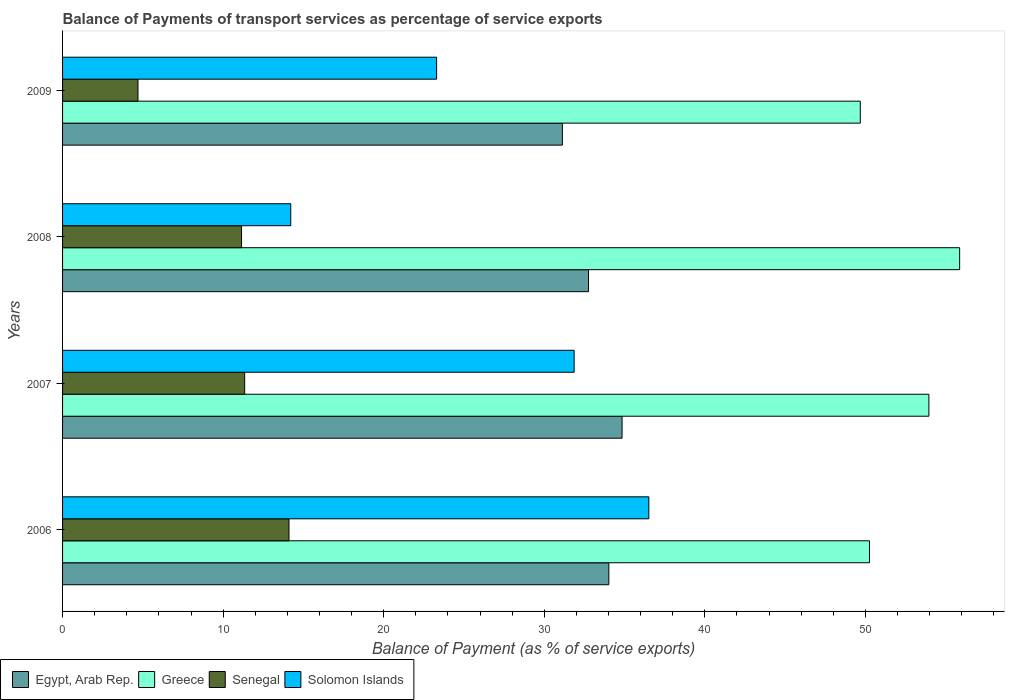How many different coloured bars are there?
Your answer should be compact. 4. How many groups of bars are there?
Provide a short and direct response. 4. Are the number of bars per tick equal to the number of legend labels?
Keep it short and to the point. Yes. Are the number of bars on each tick of the Y-axis equal?
Keep it short and to the point. Yes. How many bars are there on the 1st tick from the top?
Offer a very short reply. 4. How many bars are there on the 1st tick from the bottom?
Ensure brevity in your answer.  4. What is the label of the 4th group of bars from the top?
Offer a terse response. 2006. In how many cases, is the number of bars for a given year not equal to the number of legend labels?
Make the answer very short. 0. What is the balance of payments of transport services in Solomon Islands in 2007?
Provide a short and direct response. 31.86. Across all years, what is the maximum balance of payments of transport services in Egypt, Arab Rep.?
Offer a terse response. 34.84. Across all years, what is the minimum balance of payments of transport services in Solomon Islands?
Provide a succinct answer. 14.21. What is the total balance of payments of transport services in Solomon Islands in the graph?
Your answer should be very brief. 105.88. What is the difference between the balance of payments of transport services in Egypt, Arab Rep. in 2006 and that in 2008?
Give a very brief answer. 1.27. What is the difference between the balance of payments of transport services in Egypt, Arab Rep. in 2006 and the balance of payments of transport services in Senegal in 2008?
Your answer should be compact. 22.87. What is the average balance of payments of transport services in Solomon Islands per year?
Offer a very short reply. 26.47. In the year 2006, what is the difference between the balance of payments of transport services in Solomon Islands and balance of payments of transport services in Senegal?
Provide a succinct answer. 22.41. What is the ratio of the balance of payments of transport services in Senegal in 2007 to that in 2008?
Your response must be concise. 1.02. Is the balance of payments of transport services in Senegal in 2007 less than that in 2009?
Your answer should be very brief. No. What is the difference between the highest and the second highest balance of payments of transport services in Senegal?
Give a very brief answer. 2.76. What is the difference between the highest and the lowest balance of payments of transport services in Greece?
Provide a short and direct response. 6.19. Is it the case that in every year, the sum of the balance of payments of transport services in Solomon Islands and balance of payments of transport services in Senegal is greater than the sum of balance of payments of transport services in Egypt, Arab Rep. and balance of payments of transport services in Greece?
Provide a succinct answer. Yes. What does the 1st bar from the top in 2009 represents?
Provide a succinct answer. Solomon Islands. What does the 3rd bar from the bottom in 2006 represents?
Provide a short and direct response. Senegal. Is it the case that in every year, the sum of the balance of payments of transport services in Greece and balance of payments of transport services in Senegal is greater than the balance of payments of transport services in Solomon Islands?
Provide a succinct answer. Yes. How many bars are there?
Offer a very short reply. 16. What is the difference between two consecutive major ticks on the X-axis?
Offer a terse response. 10. Are the values on the major ticks of X-axis written in scientific E-notation?
Provide a succinct answer. No. Does the graph contain any zero values?
Keep it short and to the point. No. How are the legend labels stacked?
Provide a short and direct response. Horizontal. What is the title of the graph?
Offer a terse response. Balance of Payments of transport services as percentage of service exports. What is the label or title of the X-axis?
Provide a short and direct response. Balance of Payment (as % of service exports). What is the label or title of the Y-axis?
Your response must be concise. Years. What is the Balance of Payment (as % of service exports) of Egypt, Arab Rep. in 2006?
Keep it short and to the point. 34.02. What is the Balance of Payment (as % of service exports) in Greece in 2006?
Your answer should be very brief. 50.25. What is the Balance of Payment (as % of service exports) in Senegal in 2006?
Keep it short and to the point. 14.1. What is the Balance of Payment (as % of service exports) of Solomon Islands in 2006?
Your response must be concise. 36.51. What is the Balance of Payment (as % of service exports) in Egypt, Arab Rep. in 2007?
Offer a terse response. 34.84. What is the Balance of Payment (as % of service exports) of Greece in 2007?
Ensure brevity in your answer.  53.95. What is the Balance of Payment (as % of service exports) of Senegal in 2007?
Ensure brevity in your answer.  11.34. What is the Balance of Payment (as % of service exports) in Solomon Islands in 2007?
Provide a succinct answer. 31.86. What is the Balance of Payment (as % of service exports) in Egypt, Arab Rep. in 2008?
Your answer should be compact. 32.76. What is the Balance of Payment (as % of service exports) of Greece in 2008?
Give a very brief answer. 55.87. What is the Balance of Payment (as % of service exports) of Senegal in 2008?
Your response must be concise. 11.15. What is the Balance of Payment (as % of service exports) of Solomon Islands in 2008?
Provide a succinct answer. 14.21. What is the Balance of Payment (as % of service exports) of Egypt, Arab Rep. in 2009?
Your answer should be compact. 31.13. What is the Balance of Payment (as % of service exports) in Greece in 2009?
Your answer should be compact. 49.68. What is the Balance of Payment (as % of service exports) of Senegal in 2009?
Your answer should be compact. 4.7. What is the Balance of Payment (as % of service exports) in Solomon Islands in 2009?
Keep it short and to the point. 23.29. Across all years, what is the maximum Balance of Payment (as % of service exports) of Egypt, Arab Rep.?
Your answer should be very brief. 34.84. Across all years, what is the maximum Balance of Payment (as % of service exports) in Greece?
Your answer should be compact. 55.87. Across all years, what is the maximum Balance of Payment (as % of service exports) of Senegal?
Your answer should be compact. 14.1. Across all years, what is the maximum Balance of Payment (as % of service exports) in Solomon Islands?
Give a very brief answer. 36.51. Across all years, what is the minimum Balance of Payment (as % of service exports) of Egypt, Arab Rep.?
Provide a short and direct response. 31.13. Across all years, what is the minimum Balance of Payment (as % of service exports) in Greece?
Make the answer very short. 49.68. Across all years, what is the minimum Balance of Payment (as % of service exports) in Senegal?
Your response must be concise. 4.7. Across all years, what is the minimum Balance of Payment (as % of service exports) in Solomon Islands?
Give a very brief answer. 14.21. What is the total Balance of Payment (as % of service exports) of Egypt, Arab Rep. in the graph?
Provide a short and direct response. 132.75. What is the total Balance of Payment (as % of service exports) of Greece in the graph?
Offer a terse response. 209.75. What is the total Balance of Payment (as % of service exports) of Senegal in the graph?
Offer a terse response. 41.29. What is the total Balance of Payment (as % of service exports) in Solomon Islands in the graph?
Provide a short and direct response. 105.88. What is the difference between the Balance of Payment (as % of service exports) of Egypt, Arab Rep. in 2006 and that in 2007?
Make the answer very short. -0.82. What is the difference between the Balance of Payment (as % of service exports) in Greece in 2006 and that in 2007?
Keep it short and to the point. -3.7. What is the difference between the Balance of Payment (as % of service exports) of Senegal in 2006 and that in 2007?
Provide a succinct answer. 2.76. What is the difference between the Balance of Payment (as % of service exports) of Solomon Islands in 2006 and that in 2007?
Provide a succinct answer. 4.65. What is the difference between the Balance of Payment (as % of service exports) of Egypt, Arab Rep. in 2006 and that in 2008?
Offer a very short reply. 1.27. What is the difference between the Balance of Payment (as % of service exports) of Greece in 2006 and that in 2008?
Provide a short and direct response. -5.61. What is the difference between the Balance of Payment (as % of service exports) of Senegal in 2006 and that in 2008?
Keep it short and to the point. 2.95. What is the difference between the Balance of Payment (as % of service exports) in Solomon Islands in 2006 and that in 2008?
Make the answer very short. 22.3. What is the difference between the Balance of Payment (as % of service exports) of Egypt, Arab Rep. in 2006 and that in 2009?
Provide a short and direct response. 2.89. What is the difference between the Balance of Payment (as % of service exports) of Greece in 2006 and that in 2009?
Keep it short and to the point. 0.57. What is the difference between the Balance of Payment (as % of service exports) of Senegal in 2006 and that in 2009?
Your answer should be compact. 9.4. What is the difference between the Balance of Payment (as % of service exports) in Solomon Islands in 2006 and that in 2009?
Keep it short and to the point. 13.22. What is the difference between the Balance of Payment (as % of service exports) in Egypt, Arab Rep. in 2007 and that in 2008?
Give a very brief answer. 2.09. What is the difference between the Balance of Payment (as % of service exports) of Greece in 2007 and that in 2008?
Offer a terse response. -1.92. What is the difference between the Balance of Payment (as % of service exports) of Senegal in 2007 and that in 2008?
Provide a short and direct response. 0.19. What is the difference between the Balance of Payment (as % of service exports) in Solomon Islands in 2007 and that in 2008?
Ensure brevity in your answer.  17.65. What is the difference between the Balance of Payment (as % of service exports) in Egypt, Arab Rep. in 2007 and that in 2009?
Offer a terse response. 3.72. What is the difference between the Balance of Payment (as % of service exports) of Greece in 2007 and that in 2009?
Offer a terse response. 4.27. What is the difference between the Balance of Payment (as % of service exports) of Senegal in 2007 and that in 2009?
Keep it short and to the point. 6.64. What is the difference between the Balance of Payment (as % of service exports) in Solomon Islands in 2007 and that in 2009?
Ensure brevity in your answer.  8.57. What is the difference between the Balance of Payment (as % of service exports) of Egypt, Arab Rep. in 2008 and that in 2009?
Make the answer very short. 1.63. What is the difference between the Balance of Payment (as % of service exports) in Greece in 2008 and that in 2009?
Offer a very short reply. 6.19. What is the difference between the Balance of Payment (as % of service exports) of Senegal in 2008 and that in 2009?
Keep it short and to the point. 6.45. What is the difference between the Balance of Payment (as % of service exports) in Solomon Islands in 2008 and that in 2009?
Provide a short and direct response. -9.08. What is the difference between the Balance of Payment (as % of service exports) in Egypt, Arab Rep. in 2006 and the Balance of Payment (as % of service exports) in Greece in 2007?
Your answer should be compact. -19.93. What is the difference between the Balance of Payment (as % of service exports) in Egypt, Arab Rep. in 2006 and the Balance of Payment (as % of service exports) in Senegal in 2007?
Give a very brief answer. 22.68. What is the difference between the Balance of Payment (as % of service exports) of Egypt, Arab Rep. in 2006 and the Balance of Payment (as % of service exports) of Solomon Islands in 2007?
Provide a succinct answer. 2.16. What is the difference between the Balance of Payment (as % of service exports) in Greece in 2006 and the Balance of Payment (as % of service exports) in Senegal in 2007?
Make the answer very short. 38.91. What is the difference between the Balance of Payment (as % of service exports) in Greece in 2006 and the Balance of Payment (as % of service exports) in Solomon Islands in 2007?
Provide a succinct answer. 18.39. What is the difference between the Balance of Payment (as % of service exports) in Senegal in 2006 and the Balance of Payment (as % of service exports) in Solomon Islands in 2007?
Give a very brief answer. -17.76. What is the difference between the Balance of Payment (as % of service exports) of Egypt, Arab Rep. in 2006 and the Balance of Payment (as % of service exports) of Greece in 2008?
Give a very brief answer. -21.85. What is the difference between the Balance of Payment (as % of service exports) in Egypt, Arab Rep. in 2006 and the Balance of Payment (as % of service exports) in Senegal in 2008?
Make the answer very short. 22.87. What is the difference between the Balance of Payment (as % of service exports) in Egypt, Arab Rep. in 2006 and the Balance of Payment (as % of service exports) in Solomon Islands in 2008?
Make the answer very short. 19.81. What is the difference between the Balance of Payment (as % of service exports) in Greece in 2006 and the Balance of Payment (as % of service exports) in Senegal in 2008?
Ensure brevity in your answer.  39.11. What is the difference between the Balance of Payment (as % of service exports) in Greece in 2006 and the Balance of Payment (as % of service exports) in Solomon Islands in 2008?
Your response must be concise. 36.04. What is the difference between the Balance of Payment (as % of service exports) of Senegal in 2006 and the Balance of Payment (as % of service exports) of Solomon Islands in 2008?
Your response must be concise. -0.11. What is the difference between the Balance of Payment (as % of service exports) in Egypt, Arab Rep. in 2006 and the Balance of Payment (as % of service exports) in Greece in 2009?
Offer a terse response. -15.66. What is the difference between the Balance of Payment (as % of service exports) in Egypt, Arab Rep. in 2006 and the Balance of Payment (as % of service exports) in Senegal in 2009?
Offer a very short reply. 29.32. What is the difference between the Balance of Payment (as % of service exports) in Egypt, Arab Rep. in 2006 and the Balance of Payment (as % of service exports) in Solomon Islands in 2009?
Your answer should be very brief. 10.73. What is the difference between the Balance of Payment (as % of service exports) in Greece in 2006 and the Balance of Payment (as % of service exports) in Senegal in 2009?
Make the answer very short. 45.56. What is the difference between the Balance of Payment (as % of service exports) in Greece in 2006 and the Balance of Payment (as % of service exports) in Solomon Islands in 2009?
Your answer should be compact. 26.96. What is the difference between the Balance of Payment (as % of service exports) of Senegal in 2006 and the Balance of Payment (as % of service exports) of Solomon Islands in 2009?
Provide a short and direct response. -9.19. What is the difference between the Balance of Payment (as % of service exports) in Egypt, Arab Rep. in 2007 and the Balance of Payment (as % of service exports) in Greece in 2008?
Make the answer very short. -21.02. What is the difference between the Balance of Payment (as % of service exports) in Egypt, Arab Rep. in 2007 and the Balance of Payment (as % of service exports) in Senegal in 2008?
Offer a terse response. 23.7. What is the difference between the Balance of Payment (as % of service exports) of Egypt, Arab Rep. in 2007 and the Balance of Payment (as % of service exports) of Solomon Islands in 2008?
Your answer should be compact. 20.63. What is the difference between the Balance of Payment (as % of service exports) in Greece in 2007 and the Balance of Payment (as % of service exports) in Senegal in 2008?
Offer a very short reply. 42.81. What is the difference between the Balance of Payment (as % of service exports) in Greece in 2007 and the Balance of Payment (as % of service exports) in Solomon Islands in 2008?
Keep it short and to the point. 39.74. What is the difference between the Balance of Payment (as % of service exports) in Senegal in 2007 and the Balance of Payment (as % of service exports) in Solomon Islands in 2008?
Give a very brief answer. -2.87. What is the difference between the Balance of Payment (as % of service exports) in Egypt, Arab Rep. in 2007 and the Balance of Payment (as % of service exports) in Greece in 2009?
Give a very brief answer. -14.84. What is the difference between the Balance of Payment (as % of service exports) in Egypt, Arab Rep. in 2007 and the Balance of Payment (as % of service exports) in Senegal in 2009?
Make the answer very short. 30.15. What is the difference between the Balance of Payment (as % of service exports) in Egypt, Arab Rep. in 2007 and the Balance of Payment (as % of service exports) in Solomon Islands in 2009?
Offer a terse response. 11.55. What is the difference between the Balance of Payment (as % of service exports) of Greece in 2007 and the Balance of Payment (as % of service exports) of Senegal in 2009?
Give a very brief answer. 49.26. What is the difference between the Balance of Payment (as % of service exports) of Greece in 2007 and the Balance of Payment (as % of service exports) of Solomon Islands in 2009?
Provide a short and direct response. 30.66. What is the difference between the Balance of Payment (as % of service exports) of Senegal in 2007 and the Balance of Payment (as % of service exports) of Solomon Islands in 2009?
Ensure brevity in your answer.  -11.95. What is the difference between the Balance of Payment (as % of service exports) in Egypt, Arab Rep. in 2008 and the Balance of Payment (as % of service exports) in Greece in 2009?
Ensure brevity in your answer.  -16.93. What is the difference between the Balance of Payment (as % of service exports) of Egypt, Arab Rep. in 2008 and the Balance of Payment (as % of service exports) of Senegal in 2009?
Offer a terse response. 28.06. What is the difference between the Balance of Payment (as % of service exports) in Egypt, Arab Rep. in 2008 and the Balance of Payment (as % of service exports) in Solomon Islands in 2009?
Your answer should be very brief. 9.46. What is the difference between the Balance of Payment (as % of service exports) of Greece in 2008 and the Balance of Payment (as % of service exports) of Senegal in 2009?
Offer a very short reply. 51.17. What is the difference between the Balance of Payment (as % of service exports) of Greece in 2008 and the Balance of Payment (as % of service exports) of Solomon Islands in 2009?
Your answer should be very brief. 32.57. What is the difference between the Balance of Payment (as % of service exports) in Senegal in 2008 and the Balance of Payment (as % of service exports) in Solomon Islands in 2009?
Provide a succinct answer. -12.15. What is the average Balance of Payment (as % of service exports) in Egypt, Arab Rep. per year?
Your response must be concise. 33.19. What is the average Balance of Payment (as % of service exports) in Greece per year?
Offer a terse response. 52.44. What is the average Balance of Payment (as % of service exports) of Senegal per year?
Your response must be concise. 10.32. What is the average Balance of Payment (as % of service exports) of Solomon Islands per year?
Provide a succinct answer. 26.47. In the year 2006, what is the difference between the Balance of Payment (as % of service exports) in Egypt, Arab Rep. and Balance of Payment (as % of service exports) in Greece?
Keep it short and to the point. -16.23. In the year 2006, what is the difference between the Balance of Payment (as % of service exports) in Egypt, Arab Rep. and Balance of Payment (as % of service exports) in Senegal?
Keep it short and to the point. 19.92. In the year 2006, what is the difference between the Balance of Payment (as % of service exports) in Egypt, Arab Rep. and Balance of Payment (as % of service exports) in Solomon Islands?
Ensure brevity in your answer.  -2.49. In the year 2006, what is the difference between the Balance of Payment (as % of service exports) of Greece and Balance of Payment (as % of service exports) of Senegal?
Give a very brief answer. 36.15. In the year 2006, what is the difference between the Balance of Payment (as % of service exports) of Greece and Balance of Payment (as % of service exports) of Solomon Islands?
Ensure brevity in your answer.  13.74. In the year 2006, what is the difference between the Balance of Payment (as % of service exports) in Senegal and Balance of Payment (as % of service exports) in Solomon Islands?
Your answer should be compact. -22.41. In the year 2007, what is the difference between the Balance of Payment (as % of service exports) of Egypt, Arab Rep. and Balance of Payment (as % of service exports) of Greece?
Make the answer very short. -19.11. In the year 2007, what is the difference between the Balance of Payment (as % of service exports) of Egypt, Arab Rep. and Balance of Payment (as % of service exports) of Senegal?
Your answer should be very brief. 23.5. In the year 2007, what is the difference between the Balance of Payment (as % of service exports) in Egypt, Arab Rep. and Balance of Payment (as % of service exports) in Solomon Islands?
Give a very brief answer. 2.98. In the year 2007, what is the difference between the Balance of Payment (as % of service exports) in Greece and Balance of Payment (as % of service exports) in Senegal?
Offer a terse response. 42.61. In the year 2007, what is the difference between the Balance of Payment (as % of service exports) of Greece and Balance of Payment (as % of service exports) of Solomon Islands?
Give a very brief answer. 22.09. In the year 2007, what is the difference between the Balance of Payment (as % of service exports) in Senegal and Balance of Payment (as % of service exports) in Solomon Islands?
Your answer should be very brief. -20.52. In the year 2008, what is the difference between the Balance of Payment (as % of service exports) in Egypt, Arab Rep. and Balance of Payment (as % of service exports) in Greece?
Your answer should be very brief. -23.11. In the year 2008, what is the difference between the Balance of Payment (as % of service exports) of Egypt, Arab Rep. and Balance of Payment (as % of service exports) of Senegal?
Your response must be concise. 21.61. In the year 2008, what is the difference between the Balance of Payment (as % of service exports) in Egypt, Arab Rep. and Balance of Payment (as % of service exports) in Solomon Islands?
Offer a terse response. 18.54. In the year 2008, what is the difference between the Balance of Payment (as % of service exports) of Greece and Balance of Payment (as % of service exports) of Senegal?
Your response must be concise. 44.72. In the year 2008, what is the difference between the Balance of Payment (as % of service exports) in Greece and Balance of Payment (as % of service exports) in Solomon Islands?
Offer a terse response. 41.66. In the year 2008, what is the difference between the Balance of Payment (as % of service exports) of Senegal and Balance of Payment (as % of service exports) of Solomon Islands?
Ensure brevity in your answer.  -3.06. In the year 2009, what is the difference between the Balance of Payment (as % of service exports) of Egypt, Arab Rep. and Balance of Payment (as % of service exports) of Greece?
Offer a very short reply. -18.55. In the year 2009, what is the difference between the Balance of Payment (as % of service exports) in Egypt, Arab Rep. and Balance of Payment (as % of service exports) in Senegal?
Ensure brevity in your answer.  26.43. In the year 2009, what is the difference between the Balance of Payment (as % of service exports) in Egypt, Arab Rep. and Balance of Payment (as % of service exports) in Solomon Islands?
Provide a succinct answer. 7.83. In the year 2009, what is the difference between the Balance of Payment (as % of service exports) of Greece and Balance of Payment (as % of service exports) of Senegal?
Offer a very short reply. 44.98. In the year 2009, what is the difference between the Balance of Payment (as % of service exports) of Greece and Balance of Payment (as % of service exports) of Solomon Islands?
Offer a terse response. 26.39. In the year 2009, what is the difference between the Balance of Payment (as % of service exports) in Senegal and Balance of Payment (as % of service exports) in Solomon Islands?
Your response must be concise. -18.6. What is the ratio of the Balance of Payment (as % of service exports) of Egypt, Arab Rep. in 2006 to that in 2007?
Keep it short and to the point. 0.98. What is the ratio of the Balance of Payment (as % of service exports) of Greece in 2006 to that in 2007?
Provide a succinct answer. 0.93. What is the ratio of the Balance of Payment (as % of service exports) of Senegal in 2006 to that in 2007?
Your response must be concise. 1.24. What is the ratio of the Balance of Payment (as % of service exports) of Solomon Islands in 2006 to that in 2007?
Offer a terse response. 1.15. What is the ratio of the Balance of Payment (as % of service exports) of Egypt, Arab Rep. in 2006 to that in 2008?
Keep it short and to the point. 1.04. What is the ratio of the Balance of Payment (as % of service exports) of Greece in 2006 to that in 2008?
Your answer should be very brief. 0.9. What is the ratio of the Balance of Payment (as % of service exports) of Senegal in 2006 to that in 2008?
Provide a succinct answer. 1.26. What is the ratio of the Balance of Payment (as % of service exports) in Solomon Islands in 2006 to that in 2008?
Provide a succinct answer. 2.57. What is the ratio of the Balance of Payment (as % of service exports) of Egypt, Arab Rep. in 2006 to that in 2009?
Give a very brief answer. 1.09. What is the ratio of the Balance of Payment (as % of service exports) of Greece in 2006 to that in 2009?
Your answer should be very brief. 1.01. What is the ratio of the Balance of Payment (as % of service exports) of Senegal in 2006 to that in 2009?
Your response must be concise. 3. What is the ratio of the Balance of Payment (as % of service exports) of Solomon Islands in 2006 to that in 2009?
Offer a very short reply. 1.57. What is the ratio of the Balance of Payment (as % of service exports) of Egypt, Arab Rep. in 2007 to that in 2008?
Your answer should be compact. 1.06. What is the ratio of the Balance of Payment (as % of service exports) in Greece in 2007 to that in 2008?
Provide a succinct answer. 0.97. What is the ratio of the Balance of Payment (as % of service exports) in Senegal in 2007 to that in 2008?
Offer a terse response. 1.02. What is the ratio of the Balance of Payment (as % of service exports) of Solomon Islands in 2007 to that in 2008?
Provide a succinct answer. 2.24. What is the ratio of the Balance of Payment (as % of service exports) of Egypt, Arab Rep. in 2007 to that in 2009?
Keep it short and to the point. 1.12. What is the ratio of the Balance of Payment (as % of service exports) in Greece in 2007 to that in 2009?
Offer a terse response. 1.09. What is the ratio of the Balance of Payment (as % of service exports) in Senegal in 2007 to that in 2009?
Give a very brief answer. 2.41. What is the ratio of the Balance of Payment (as % of service exports) of Solomon Islands in 2007 to that in 2009?
Your answer should be very brief. 1.37. What is the ratio of the Balance of Payment (as % of service exports) of Egypt, Arab Rep. in 2008 to that in 2009?
Ensure brevity in your answer.  1.05. What is the ratio of the Balance of Payment (as % of service exports) of Greece in 2008 to that in 2009?
Provide a succinct answer. 1.12. What is the ratio of the Balance of Payment (as % of service exports) of Senegal in 2008 to that in 2009?
Your answer should be very brief. 2.37. What is the ratio of the Balance of Payment (as % of service exports) in Solomon Islands in 2008 to that in 2009?
Give a very brief answer. 0.61. What is the difference between the highest and the second highest Balance of Payment (as % of service exports) of Egypt, Arab Rep.?
Keep it short and to the point. 0.82. What is the difference between the highest and the second highest Balance of Payment (as % of service exports) in Greece?
Your answer should be compact. 1.92. What is the difference between the highest and the second highest Balance of Payment (as % of service exports) of Senegal?
Keep it short and to the point. 2.76. What is the difference between the highest and the second highest Balance of Payment (as % of service exports) of Solomon Islands?
Your response must be concise. 4.65. What is the difference between the highest and the lowest Balance of Payment (as % of service exports) of Egypt, Arab Rep.?
Make the answer very short. 3.72. What is the difference between the highest and the lowest Balance of Payment (as % of service exports) of Greece?
Provide a short and direct response. 6.19. What is the difference between the highest and the lowest Balance of Payment (as % of service exports) of Senegal?
Your response must be concise. 9.4. What is the difference between the highest and the lowest Balance of Payment (as % of service exports) of Solomon Islands?
Make the answer very short. 22.3. 